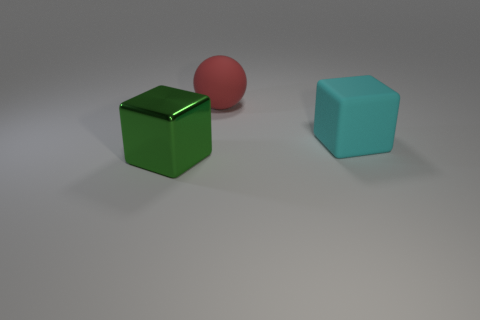The thing that is behind the cyan rubber block has what shape?
Provide a succinct answer. Sphere. Are the cyan object and the big red thing made of the same material?
Give a very brief answer. Yes. What number of big matte things are to the right of the green metal thing?
Provide a succinct answer. 2. The object in front of the rubber thing that is in front of the red matte sphere is what shape?
Provide a succinct answer. Cube. Are there any other things that are the same shape as the large red object?
Your answer should be very brief. No. Is the number of big cyan objects in front of the red rubber object greater than the number of small cyan matte blocks?
Your answer should be compact. Yes. How many rubber balls are to the left of the object in front of the big cyan matte object?
Your answer should be very brief. 0. What is the shape of the large thing behind the cube right of the thing that is in front of the big cyan matte cube?
Keep it short and to the point. Sphere. What is the size of the cyan cube?
Provide a short and direct response. Large. Are there any big green cylinders made of the same material as the big red sphere?
Make the answer very short. No. 